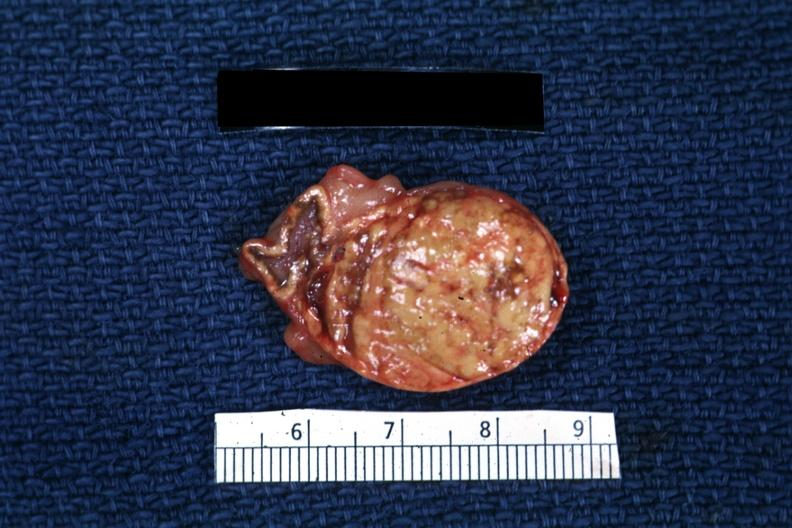what is present?
Answer the question using a single word or phrase. Endocrine 